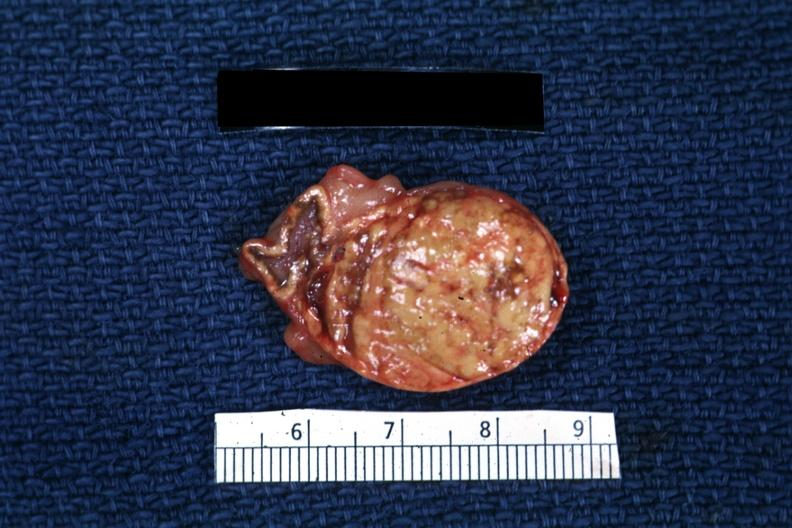what is present?
Answer the question using a single word or phrase. Endocrine 